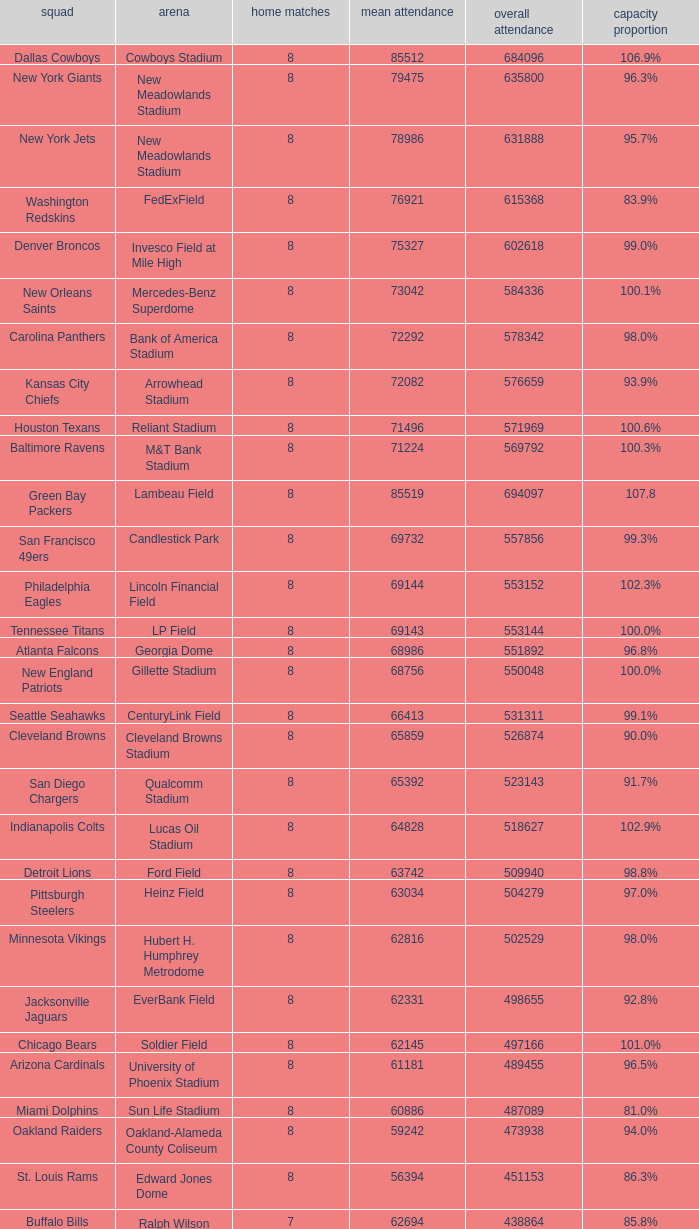What is the name of the team when the stadium is listed as Edward Jones Dome? St. Louis Rams. 